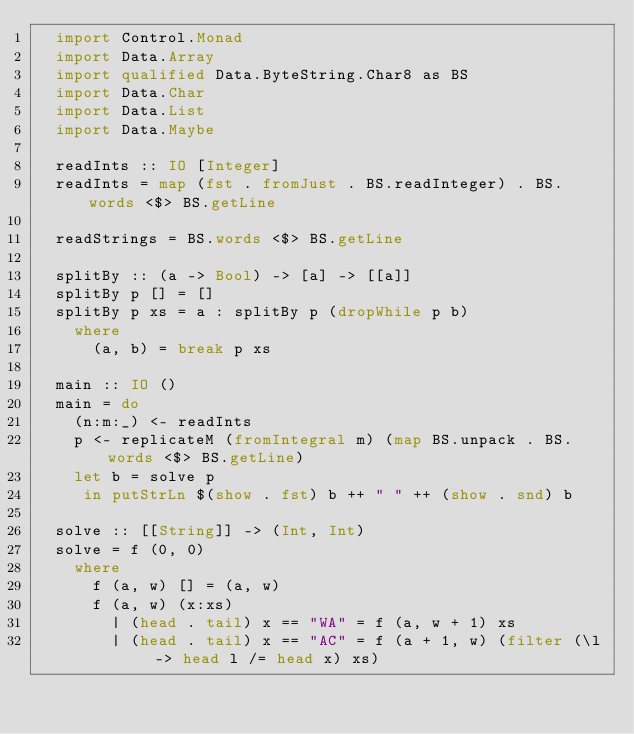<code> <loc_0><loc_0><loc_500><loc_500><_Haskell_>  import Control.Monad
  import Data.Array
  import qualified Data.ByteString.Char8 as BS
  import Data.Char
  import Data.List
  import Data.Maybe
  
  readInts :: IO [Integer]
  readInts = map (fst . fromJust . BS.readInteger) . BS.words <$> BS.getLine
  
  readStrings = BS.words <$> BS.getLine
  
  splitBy :: (a -> Bool) -> [a] -> [[a]]
  splitBy p [] = []
  splitBy p xs = a : splitBy p (dropWhile p b)
    where
      (a, b) = break p xs
  
  main :: IO ()
  main = do
    (n:m:_) <- readInts
    p <- replicateM (fromIntegral m) (map BS.unpack . BS.words <$> BS.getLine)
    let b = solve p
     in putStrLn $(show . fst) b ++ " " ++ (show . snd) b
  
  solve :: [[String]] -> (Int, Int)
  solve = f (0, 0)
    where
      f (a, w) [] = (a, w)
      f (a, w) (x:xs)
        | (head . tail) x == "WA" = f (a, w + 1) xs
        | (head . tail) x == "AC" = f (a + 1, w) (filter (\l -> head l /= head x) xs)
</code> 